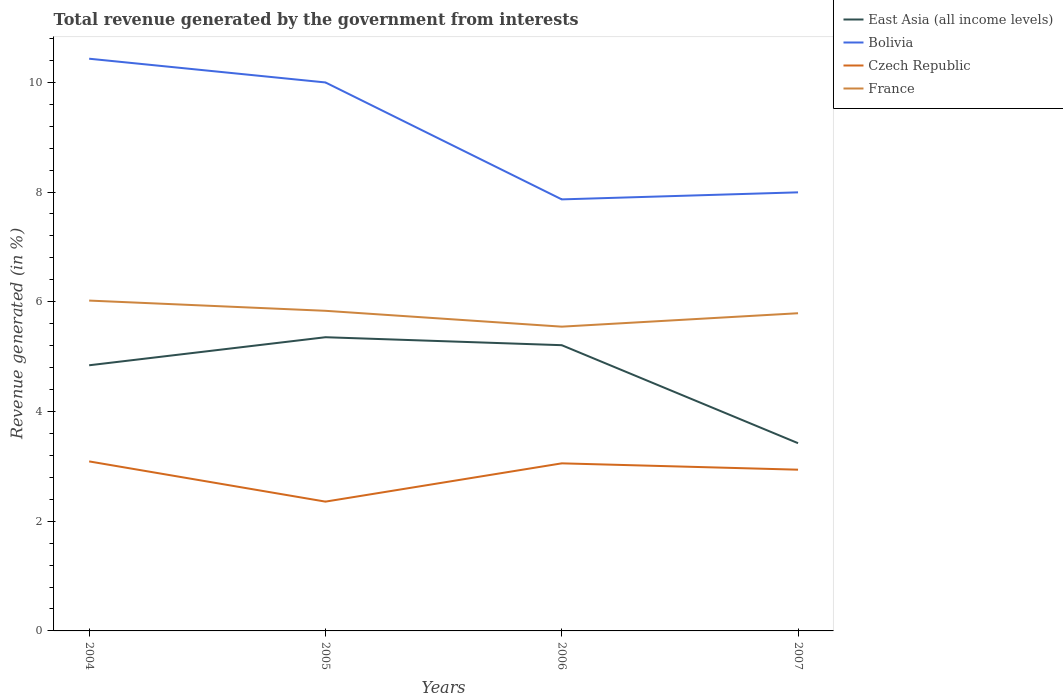How many different coloured lines are there?
Provide a short and direct response. 4. Across all years, what is the maximum total revenue generated in East Asia (all income levels)?
Provide a short and direct response. 3.42. What is the total total revenue generated in Czech Republic in the graph?
Your response must be concise. -0.7. What is the difference between the highest and the second highest total revenue generated in France?
Offer a very short reply. 0.48. How many years are there in the graph?
Make the answer very short. 4. Does the graph contain any zero values?
Provide a short and direct response. No. Where does the legend appear in the graph?
Give a very brief answer. Top right. What is the title of the graph?
Offer a terse response. Total revenue generated by the government from interests. Does "Tajikistan" appear as one of the legend labels in the graph?
Provide a succinct answer. No. What is the label or title of the Y-axis?
Your response must be concise. Revenue generated (in %). What is the Revenue generated (in %) in East Asia (all income levels) in 2004?
Provide a short and direct response. 4.84. What is the Revenue generated (in %) in Bolivia in 2004?
Ensure brevity in your answer.  10.43. What is the Revenue generated (in %) of Czech Republic in 2004?
Your answer should be very brief. 3.09. What is the Revenue generated (in %) in France in 2004?
Your response must be concise. 6.02. What is the Revenue generated (in %) of East Asia (all income levels) in 2005?
Provide a succinct answer. 5.35. What is the Revenue generated (in %) of Bolivia in 2005?
Your answer should be very brief. 10. What is the Revenue generated (in %) in Czech Republic in 2005?
Provide a short and direct response. 2.36. What is the Revenue generated (in %) in France in 2005?
Your response must be concise. 5.84. What is the Revenue generated (in %) of East Asia (all income levels) in 2006?
Make the answer very short. 5.21. What is the Revenue generated (in %) in Bolivia in 2006?
Your answer should be very brief. 7.87. What is the Revenue generated (in %) of Czech Republic in 2006?
Offer a very short reply. 3.05. What is the Revenue generated (in %) in France in 2006?
Give a very brief answer. 5.55. What is the Revenue generated (in %) of East Asia (all income levels) in 2007?
Keep it short and to the point. 3.42. What is the Revenue generated (in %) of Bolivia in 2007?
Offer a very short reply. 7.99. What is the Revenue generated (in %) of Czech Republic in 2007?
Ensure brevity in your answer.  2.94. What is the Revenue generated (in %) of France in 2007?
Offer a terse response. 5.79. Across all years, what is the maximum Revenue generated (in %) in East Asia (all income levels)?
Your response must be concise. 5.35. Across all years, what is the maximum Revenue generated (in %) in Bolivia?
Ensure brevity in your answer.  10.43. Across all years, what is the maximum Revenue generated (in %) of Czech Republic?
Give a very brief answer. 3.09. Across all years, what is the maximum Revenue generated (in %) in France?
Provide a succinct answer. 6.02. Across all years, what is the minimum Revenue generated (in %) in East Asia (all income levels)?
Ensure brevity in your answer.  3.42. Across all years, what is the minimum Revenue generated (in %) in Bolivia?
Keep it short and to the point. 7.87. Across all years, what is the minimum Revenue generated (in %) of Czech Republic?
Give a very brief answer. 2.36. Across all years, what is the minimum Revenue generated (in %) of France?
Provide a succinct answer. 5.55. What is the total Revenue generated (in %) of East Asia (all income levels) in the graph?
Your answer should be very brief. 18.83. What is the total Revenue generated (in %) in Bolivia in the graph?
Your response must be concise. 36.29. What is the total Revenue generated (in %) in Czech Republic in the graph?
Offer a very short reply. 11.44. What is the total Revenue generated (in %) of France in the graph?
Offer a very short reply. 23.19. What is the difference between the Revenue generated (in %) in East Asia (all income levels) in 2004 and that in 2005?
Your response must be concise. -0.51. What is the difference between the Revenue generated (in %) of Bolivia in 2004 and that in 2005?
Give a very brief answer. 0.43. What is the difference between the Revenue generated (in %) of Czech Republic in 2004 and that in 2005?
Provide a succinct answer. 0.73. What is the difference between the Revenue generated (in %) of France in 2004 and that in 2005?
Offer a terse response. 0.19. What is the difference between the Revenue generated (in %) of East Asia (all income levels) in 2004 and that in 2006?
Make the answer very short. -0.37. What is the difference between the Revenue generated (in %) in Bolivia in 2004 and that in 2006?
Provide a short and direct response. 2.56. What is the difference between the Revenue generated (in %) in Czech Republic in 2004 and that in 2006?
Provide a short and direct response. 0.04. What is the difference between the Revenue generated (in %) in France in 2004 and that in 2006?
Your answer should be very brief. 0.48. What is the difference between the Revenue generated (in %) in East Asia (all income levels) in 2004 and that in 2007?
Offer a terse response. 1.42. What is the difference between the Revenue generated (in %) of Bolivia in 2004 and that in 2007?
Provide a short and direct response. 2.44. What is the difference between the Revenue generated (in %) in Czech Republic in 2004 and that in 2007?
Your response must be concise. 0.15. What is the difference between the Revenue generated (in %) in France in 2004 and that in 2007?
Offer a very short reply. 0.23. What is the difference between the Revenue generated (in %) of East Asia (all income levels) in 2005 and that in 2006?
Keep it short and to the point. 0.15. What is the difference between the Revenue generated (in %) of Bolivia in 2005 and that in 2006?
Give a very brief answer. 2.13. What is the difference between the Revenue generated (in %) of Czech Republic in 2005 and that in 2006?
Make the answer very short. -0.7. What is the difference between the Revenue generated (in %) of France in 2005 and that in 2006?
Ensure brevity in your answer.  0.29. What is the difference between the Revenue generated (in %) in East Asia (all income levels) in 2005 and that in 2007?
Make the answer very short. 1.93. What is the difference between the Revenue generated (in %) in Bolivia in 2005 and that in 2007?
Offer a very short reply. 2. What is the difference between the Revenue generated (in %) of Czech Republic in 2005 and that in 2007?
Keep it short and to the point. -0.58. What is the difference between the Revenue generated (in %) of France in 2005 and that in 2007?
Your answer should be very brief. 0.04. What is the difference between the Revenue generated (in %) of East Asia (all income levels) in 2006 and that in 2007?
Your answer should be compact. 1.79. What is the difference between the Revenue generated (in %) of Bolivia in 2006 and that in 2007?
Give a very brief answer. -0.13. What is the difference between the Revenue generated (in %) of Czech Republic in 2006 and that in 2007?
Your response must be concise. 0.12. What is the difference between the Revenue generated (in %) in France in 2006 and that in 2007?
Ensure brevity in your answer.  -0.24. What is the difference between the Revenue generated (in %) in East Asia (all income levels) in 2004 and the Revenue generated (in %) in Bolivia in 2005?
Ensure brevity in your answer.  -5.16. What is the difference between the Revenue generated (in %) of East Asia (all income levels) in 2004 and the Revenue generated (in %) of Czech Republic in 2005?
Make the answer very short. 2.49. What is the difference between the Revenue generated (in %) in East Asia (all income levels) in 2004 and the Revenue generated (in %) in France in 2005?
Keep it short and to the point. -0.99. What is the difference between the Revenue generated (in %) of Bolivia in 2004 and the Revenue generated (in %) of Czech Republic in 2005?
Your answer should be compact. 8.07. What is the difference between the Revenue generated (in %) of Bolivia in 2004 and the Revenue generated (in %) of France in 2005?
Provide a short and direct response. 4.6. What is the difference between the Revenue generated (in %) in Czech Republic in 2004 and the Revenue generated (in %) in France in 2005?
Make the answer very short. -2.75. What is the difference between the Revenue generated (in %) in East Asia (all income levels) in 2004 and the Revenue generated (in %) in Bolivia in 2006?
Provide a short and direct response. -3.02. What is the difference between the Revenue generated (in %) of East Asia (all income levels) in 2004 and the Revenue generated (in %) of Czech Republic in 2006?
Your answer should be very brief. 1.79. What is the difference between the Revenue generated (in %) in East Asia (all income levels) in 2004 and the Revenue generated (in %) in France in 2006?
Ensure brevity in your answer.  -0.7. What is the difference between the Revenue generated (in %) in Bolivia in 2004 and the Revenue generated (in %) in Czech Republic in 2006?
Provide a short and direct response. 7.38. What is the difference between the Revenue generated (in %) of Bolivia in 2004 and the Revenue generated (in %) of France in 2006?
Provide a succinct answer. 4.88. What is the difference between the Revenue generated (in %) in Czech Republic in 2004 and the Revenue generated (in %) in France in 2006?
Ensure brevity in your answer.  -2.46. What is the difference between the Revenue generated (in %) of East Asia (all income levels) in 2004 and the Revenue generated (in %) of Bolivia in 2007?
Your answer should be compact. -3.15. What is the difference between the Revenue generated (in %) in East Asia (all income levels) in 2004 and the Revenue generated (in %) in Czech Republic in 2007?
Offer a terse response. 1.9. What is the difference between the Revenue generated (in %) in East Asia (all income levels) in 2004 and the Revenue generated (in %) in France in 2007?
Give a very brief answer. -0.95. What is the difference between the Revenue generated (in %) in Bolivia in 2004 and the Revenue generated (in %) in Czech Republic in 2007?
Your answer should be compact. 7.49. What is the difference between the Revenue generated (in %) in Bolivia in 2004 and the Revenue generated (in %) in France in 2007?
Make the answer very short. 4.64. What is the difference between the Revenue generated (in %) of Czech Republic in 2004 and the Revenue generated (in %) of France in 2007?
Ensure brevity in your answer.  -2.7. What is the difference between the Revenue generated (in %) of East Asia (all income levels) in 2005 and the Revenue generated (in %) of Bolivia in 2006?
Offer a very short reply. -2.51. What is the difference between the Revenue generated (in %) of East Asia (all income levels) in 2005 and the Revenue generated (in %) of Czech Republic in 2006?
Give a very brief answer. 2.3. What is the difference between the Revenue generated (in %) in East Asia (all income levels) in 2005 and the Revenue generated (in %) in France in 2006?
Provide a succinct answer. -0.19. What is the difference between the Revenue generated (in %) in Bolivia in 2005 and the Revenue generated (in %) in Czech Republic in 2006?
Your answer should be compact. 6.94. What is the difference between the Revenue generated (in %) of Bolivia in 2005 and the Revenue generated (in %) of France in 2006?
Your response must be concise. 4.45. What is the difference between the Revenue generated (in %) in Czech Republic in 2005 and the Revenue generated (in %) in France in 2006?
Offer a terse response. -3.19. What is the difference between the Revenue generated (in %) of East Asia (all income levels) in 2005 and the Revenue generated (in %) of Bolivia in 2007?
Offer a very short reply. -2.64. What is the difference between the Revenue generated (in %) of East Asia (all income levels) in 2005 and the Revenue generated (in %) of Czech Republic in 2007?
Your answer should be compact. 2.41. What is the difference between the Revenue generated (in %) in East Asia (all income levels) in 2005 and the Revenue generated (in %) in France in 2007?
Ensure brevity in your answer.  -0.44. What is the difference between the Revenue generated (in %) in Bolivia in 2005 and the Revenue generated (in %) in Czech Republic in 2007?
Offer a terse response. 7.06. What is the difference between the Revenue generated (in %) of Bolivia in 2005 and the Revenue generated (in %) of France in 2007?
Provide a short and direct response. 4.21. What is the difference between the Revenue generated (in %) of Czech Republic in 2005 and the Revenue generated (in %) of France in 2007?
Offer a very short reply. -3.43. What is the difference between the Revenue generated (in %) of East Asia (all income levels) in 2006 and the Revenue generated (in %) of Bolivia in 2007?
Your answer should be compact. -2.79. What is the difference between the Revenue generated (in %) of East Asia (all income levels) in 2006 and the Revenue generated (in %) of Czech Republic in 2007?
Ensure brevity in your answer.  2.27. What is the difference between the Revenue generated (in %) in East Asia (all income levels) in 2006 and the Revenue generated (in %) in France in 2007?
Your answer should be very brief. -0.58. What is the difference between the Revenue generated (in %) of Bolivia in 2006 and the Revenue generated (in %) of Czech Republic in 2007?
Give a very brief answer. 4.93. What is the difference between the Revenue generated (in %) in Bolivia in 2006 and the Revenue generated (in %) in France in 2007?
Offer a terse response. 2.08. What is the difference between the Revenue generated (in %) in Czech Republic in 2006 and the Revenue generated (in %) in France in 2007?
Ensure brevity in your answer.  -2.74. What is the average Revenue generated (in %) of East Asia (all income levels) per year?
Offer a terse response. 4.71. What is the average Revenue generated (in %) of Bolivia per year?
Provide a succinct answer. 9.07. What is the average Revenue generated (in %) in Czech Republic per year?
Make the answer very short. 2.86. What is the average Revenue generated (in %) in France per year?
Your response must be concise. 5.8. In the year 2004, what is the difference between the Revenue generated (in %) of East Asia (all income levels) and Revenue generated (in %) of Bolivia?
Your response must be concise. -5.59. In the year 2004, what is the difference between the Revenue generated (in %) in East Asia (all income levels) and Revenue generated (in %) in Czech Republic?
Provide a short and direct response. 1.75. In the year 2004, what is the difference between the Revenue generated (in %) in East Asia (all income levels) and Revenue generated (in %) in France?
Ensure brevity in your answer.  -1.18. In the year 2004, what is the difference between the Revenue generated (in %) in Bolivia and Revenue generated (in %) in Czech Republic?
Provide a short and direct response. 7.34. In the year 2004, what is the difference between the Revenue generated (in %) in Bolivia and Revenue generated (in %) in France?
Make the answer very short. 4.41. In the year 2004, what is the difference between the Revenue generated (in %) of Czech Republic and Revenue generated (in %) of France?
Your answer should be compact. -2.93. In the year 2005, what is the difference between the Revenue generated (in %) of East Asia (all income levels) and Revenue generated (in %) of Bolivia?
Give a very brief answer. -4.64. In the year 2005, what is the difference between the Revenue generated (in %) in East Asia (all income levels) and Revenue generated (in %) in Czech Republic?
Provide a succinct answer. 3. In the year 2005, what is the difference between the Revenue generated (in %) in East Asia (all income levels) and Revenue generated (in %) in France?
Offer a very short reply. -0.48. In the year 2005, what is the difference between the Revenue generated (in %) of Bolivia and Revenue generated (in %) of Czech Republic?
Give a very brief answer. 7.64. In the year 2005, what is the difference between the Revenue generated (in %) of Bolivia and Revenue generated (in %) of France?
Provide a short and direct response. 4.16. In the year 2005, what is the difference between the Revenue generated (in %) of Czech Republic and Revenue generated (in %) of France?
Make the answer very short. -3.48. In the year 2006, what is the difference between the Revenue generated (in %) of East Asia (all income levels) and Revenue generated (in %) of Bolivia?
Keep it short and to the point. -2.66. In the year 2006, what is the difference between the Revenue generated (in %) in East Asia (all income levels) and Revenue generated (in %) in Czech Republic?
Your answer should be very brief. 2.15. In the year 2006, what is the difference between the Revenue generated (in %) in East Asia (all income levels) and Revenue generated (in %) in France?
Provide a succinct answer. -0.34. In the year 2006, what is the difference between the Revenue generated (in %) in Bolivia and Revenue generated (in %) in Czech Republic?
Provide a short and direct response. 4.81. In the year 2006, what is the difference between the Revenue generated (in %) of Bolivia and Revenue generated (in %) of France?
Provide a short and direct response. 2.32. In the year 2006, what is the difference between the Revenue generated (in %) of Czech Republic and Revenue generated (in %) of France?
Provide a short and direct response. -2.49. In the year 2007, what is the difference between the Revenue generated (in %) of East Asia (all income levels) and Revenue generated (in %) of Bolivia?
Give a very brief answer. -4.57. In the year 2007, what is the difference between the Revenue generated (in %) of East Asia (all income levels) and Revenue generated (in %) of Czech Republic?
Give a very brief answer. 0.48. In the year 2007, what is the difference between the Revenue generated (in %) in East Asia (all income levels) and Revenue generated (in %) in France?
Keep it short and to the point. -2.37. In the year 2007, what is the difference between the Revenue generated (in %) in Bolivia and Revenue generated (in %) in Czech Republic?
Ensure brevity in your answer.  5.06. In the year 2007, what is the difference between the Revenue generated (in %) in Bolivia and Revenue generated (in %) in France?
Provide a short and direct response. 2.2. In the year 2007, what is the difference between the Revenue generated (in %) of Czech Republic and Revenue generated (in %) of France?
Keep it short and to the point. -2.85. What is the ratio of the Revenue generated (in %) in East Asia (all income levels) in 2004 to that in 2005?
Your answer should be very brief. 0.9. What is the ratio of the Revenue generated (in %) of Bolivia in 2004 to that in 2005?
Your answer should be very brief. 1.04. What is the ratio of the Revenue generated (in %) of Czech Republic in 2004 to that in 2005?
Provide a short and direct response. 1.31. What is the ratio of the Revenue generated (in %) of France in 2004 to that in 2005?
Give a very brief answer. 1.03. What is the ratio of the Revenue generated (in %) in East Asia (all income levels) in 2004 to that in 2006?
Make the answer very short. 0.93. What is the ratio of the Revenue generated (in %) in Bolivia in 2004 to that in 2006?
Your response must be concise. 1.33. What is the ratio of the Revenue generated (in %) of Czech Republic in 2004 to that in 2006?
Keep it short and to the point. 1.01. What is the ratio of the Revenue generated (in %) of France in 2004 to that in 2006?
Make the answer very short. 1.09. What is the ratio of the Revenue generated (in %) in East Asia (all income levels) in 2004 to that in 2007?
Make the answer very short. 1.41. What is the ratio of the Revenue generated (in %) of Bolivia in 2004 to that in 2007?
Provide a succinct answer. 1.3. What is the ratio of the Revenue generated (in %) of Czech Republic in 2004 to that in 2007?
Your response must be concise. 1.05. What is the ratio of the Revenue generated (in %) of France in 2004 to that in 2007?
Your answer should be very brief. 1.04. What is the ratio of the Revenue generated (in %) of East Asia (all income levels) in 2005 to that in 2006?
Your response must be concise. 1.03. What is the ratio of the Revenue generated (in %) of Bolivia in 2005 to that in 2006?
Make the answer very short. 1.27. What is the ratio of the Revenue generated (in %) in Czech Republic in 2005 to that in 2006?
Provide a succinct answer. 0.77. What is the ratio of the Revenue generated (in %) in France in 2005 to that in 2006?
Ensure brevity in your answer.  1.05. What is the ratio of the Revenue generated (in %) in East Asia (all income levels) in 2005 to that in 2007?
Your response must be concise. 1.56. What is the ratio of the Revenue generated (in %) of Bolivia in 2005 to that in 2007?
Your response must be concise. 1.25. What is the ratio of the Revenue generated (in %) in Czech Republic in 2005 to that in 2007?
Provide a short and direct response. 0.8. What is the ratio of the Revenue generated (in %) of France in 2005 to that in 2007?
Your answer should be very brief. 1.01. What is the ratio of the Revenue generated (in %) of East Asia (all income levels) in 2006 to that in 2007?
Your answer should be compact. 1.52. What is the ratio of the Revenue generated (in %) in Bolivia in 2006 to that in 2007?
Your response must be concise. 0.98. What is the ratio of the Revenue generated (in %) in Czech Republic in 2006 to that in 2007?
Give a very brief answer. 1.04. What is the ratio of the Revenue generated (in %) in France in 2006 to that in 2007?
Keep it short and to the point. 0.96. What is the difference between the highest and the second highest Revenue generated (in %) of East Asia (all income levels)?
Give a very brief answer. 0.15. What is the difference between the highest and the second highest Revenue generated (in %) of Bolivia?
Your answer should be compact. 0.43. What is the difference between the highest and the second highest Revenue generated (in %) of Czech Republic?
Offer a terse response. 0.04. What is the difference between the highest and the second highest Revenue generated (in %) of France?
Keep it short and to the point. 0.19. What is the difference between the highest and the lowest Revenue generated (in %) in East Asia (all income levels)?
Your response must be concise. 1.93. What is the difference between the highest and the lowest Revenue generated (in %) in Bolivia?
Offer a terse response. 2.56. What is the difference between the highest and the lowest Revenue generated (in %) in Czech Republic?
Ensure brevity in your answer.  0.73. What is the difference between the highest and the lowest Revenue generated (in %) of France?
Make the answer very short. 0.48. 